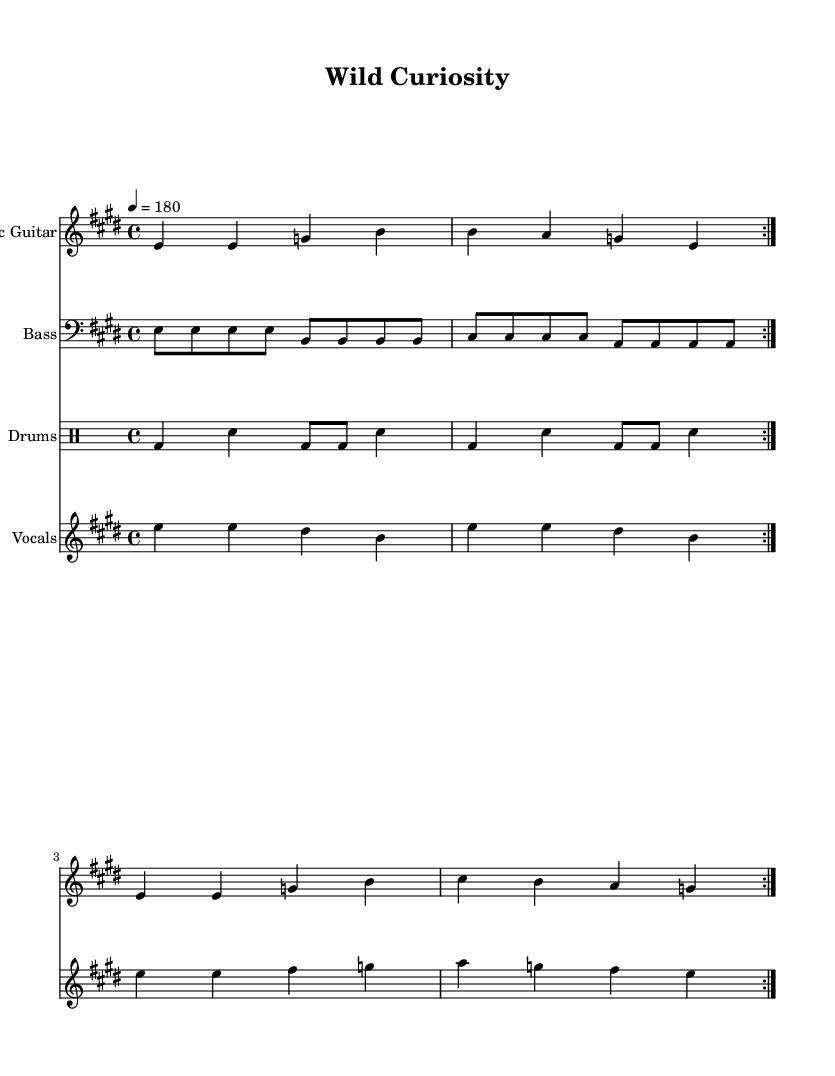What is the key signature of this music? The key signature appears at the beginning of the staff and indicates which notes are sharp or flat throughout the piece. Here, there are four sharps, which represents the key of E major.
Answer: E major What is the time signature of this music? The time signature is shown right after the key signature at the beginning of the score. It indicates how many beats are in each measure, and here it shows 4/4, meaning there are four beats in each measure.
Answer: 4/4 What is the tempo marking in this sheet music? The tempo marking is indicated at the beginning of the score and gives a sense of the speed of the music. In this case, it indicates a tempo of 180 beats per minute, which is quite fast.
Answer: 180 How many times is the verse repeated? The repeat markings (volta) indicate how many times the section is to be played. Here, the verse has been marked to repeat twice, as indicated by the repeat symbols.
Answer: 2 What instruments are included in this score? The score includes several staffs that represent different instruments. By examining the score headers, we can see that it features an Electric Guitar, Bass, Drums, and Vocals.
Answer: Electric Guitar, Bass, Drums, Vocals What is the theme of the lyrics presented in the music? By reviewing the lyrics provided under the vocal melody, we identify a sense of adventurous exploration, focusing on climbing trees, scrapping knees, exploring caves, and riding waves, which embodies youthful curiosity.
Answer: Youthful curiosity and exploration How does the song's chorus reflect punk values? The chorus lyrics emphasize breaking free and celebrating curiosity, which aligns with punk values of rebellion and freedom, common themes in punk anthems. The phrases are strong and straightforward, reflecting a direct message typical of punk music.
Answer: Rebellion and freedom 